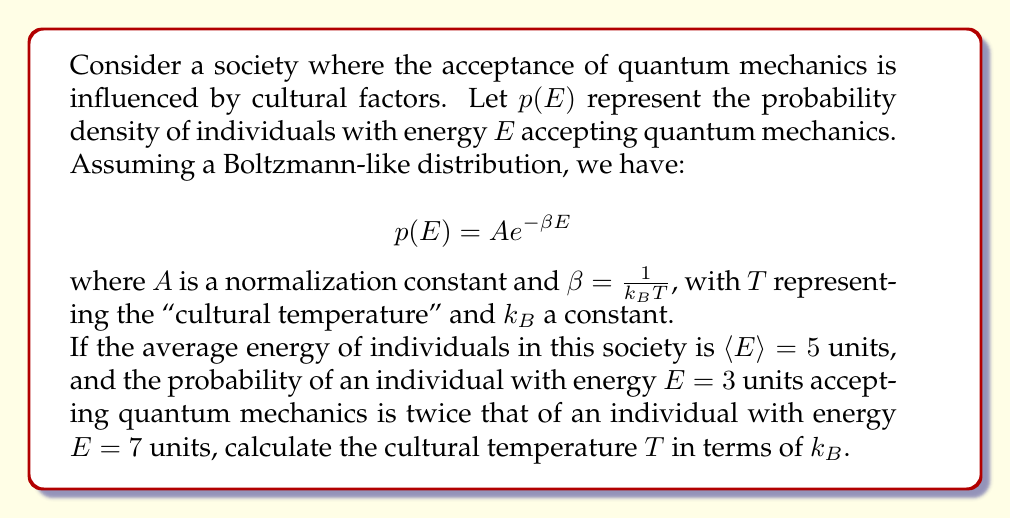Can you solve this math problem? Let's approach this step-by-step:

1) We're given that $p(3) = 2p(7)$. Using the Boltzmann-like distribution:

   $$A e^{-3\beta} = 2A e^{-7\beta}$$

2) The $A$ cancels out, leaving us with:

   $$e^{-3\beta} = 2e^{-7\beta}$$

3) Taking the natural log of both sides:

   $$-3\beta = \ln(2) - 7\beta$$

4) Solving for $\beta$:

   $$4\beta = \ln(2)$$
   $$\beta = \frac{\ln(2)}{4}$$

5) Now, we can use the fact that the average energy $\langle E \rangle = 5$. For a Boltzmann distribution, we know that:

   $$\langle E \rangle = -\frac{\partial \ln Z}{\partial \beta}$$

   where $Z$ is the partition function.

6) For a continuous energy spectrum, $Z = \int_0^{\infty} e^{-\beta E} dE = \frac{1}{\beta}$

7) Therefore:

   $$\langle E \rangle = -\frac{\partial}{\partial \beta} \ln(\frac{1}{\beta}) = \frac{1}{\beta}$$

8) Substituting our known values:

   $$5 = \frac{1}{\beta} = \frac{4}{\ln(2)}$$

9) Recall that $\beta = \frac{1}{k_B T}$. Therefore:

   $$T = \frac{1}{k_B \beta} = \frac{4}{k_B \ln(2)}$$
Answer: $T = \frac{4}{k_B \ln(2)}$ 